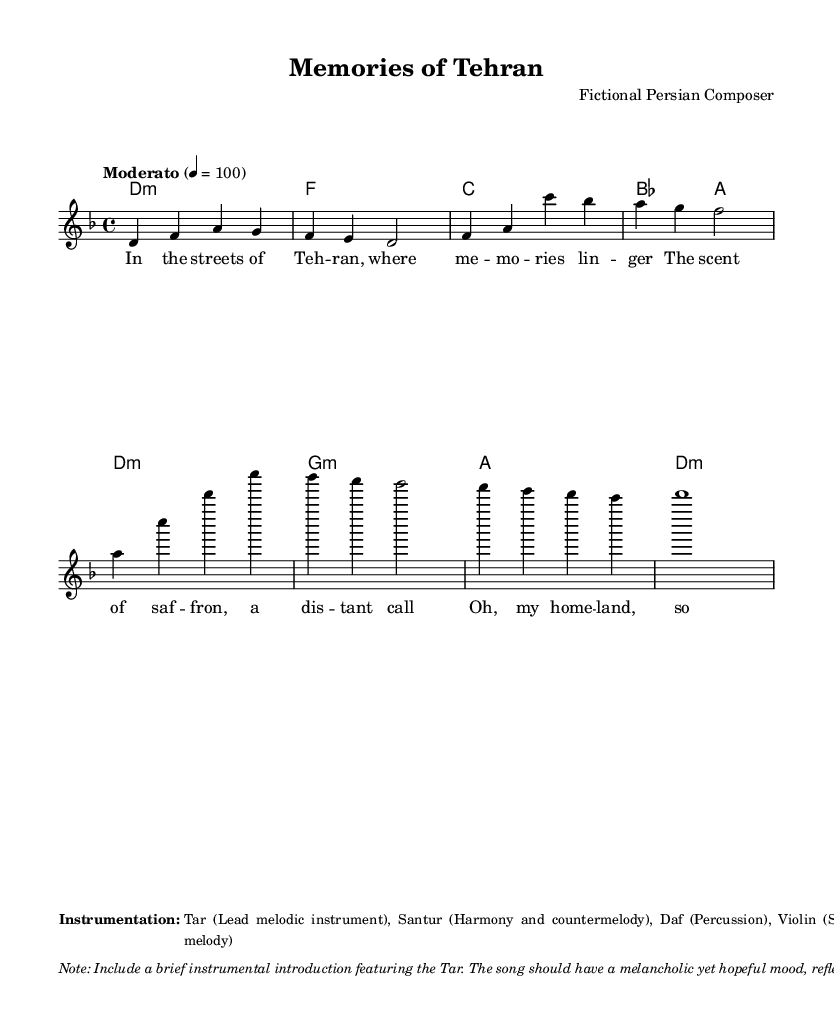What is the key signature of this music? The key signature is D minor, which has one flat (B flat). This can be identified from the key designation at the beginning of the staff in the global section.
Answer: D minor What is the time signature of this piece? The time signature is 4/4, as indicated at the start of the global section. This means there are 4 beats in a measure and the quarter note gets one beat.
Answer: 4/4 What is the tempo marking for this piece? The tempo marking is "Moderato," which suggests a moderate speed. This is stated at the beginning along with the BPM (beats per minute) marking of 100.
Answer: Moderato How many measures are in the melody? The melody consists of 8 measures, as indicated by the groupings in the melody line. Each grouping delineated by the bar lines signifies one measure.
Answer: 8 measures What is the primary emotion reflected in the lyrics? The primary emotion reflected in the lyrics is homesickness, as the lyrics express longing for the homeland and memories associated with it. The themes of distance and dreams further underscore this feeling.
Answer: Homesickness What instruments are specified for this piece? The specified instruments are Tar, Santur, Daf, and Violin. These are listed under the instrumentation section in the markup at the bottom.
Answer: Tar, Santur, Daf, Violin What style elements can be expected in the melody? The melody should incorporate traditional Persian musical elements including microtones and ornamentations, as stated in the note regarding the musical style and characteristics.
Answer: Microtones and ornamentations 